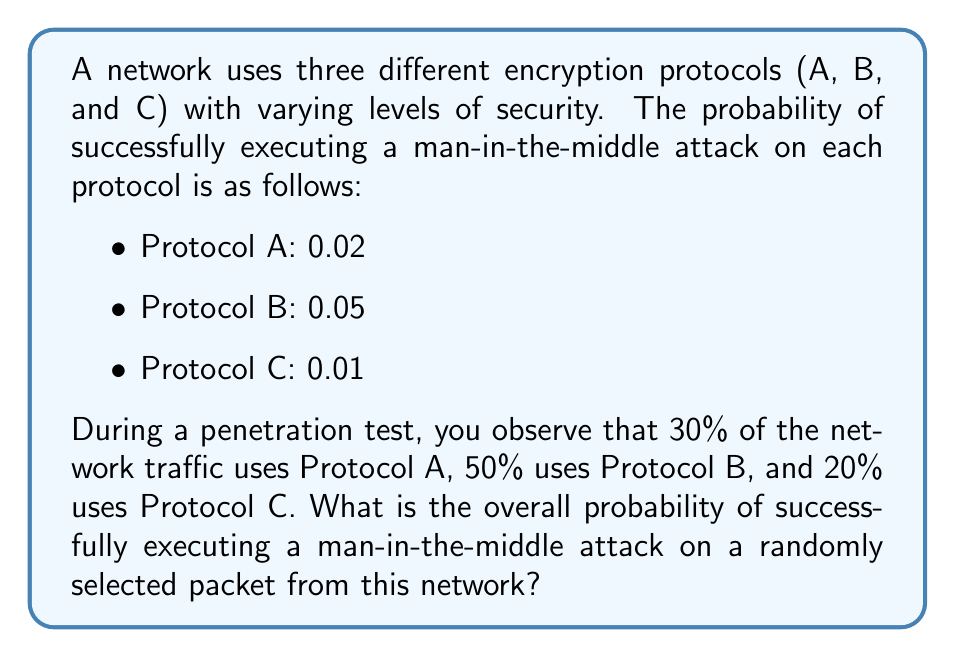Give your solution to this math problem. To solve this problem, we need to use the law of total probability. Let's break it down step-by-step:

1. Define events:
   - Let $S$ be the event of a successful man-in-the-middle attack
   - Let $A$, $B$, and $C$ represent the events of selecting a packet using Protocol A, B, and C respectively

2. Given probabilities:
   - $P(S|A) = 0.02$ (probability of success given Protocol A)
   - $P(S|B) = 0.05$ (probability of success given Protocol B)
   - $P(S|C) = 0.01$ (probability of success given Protocol C)
   - $P(A) = 0.30$ (probability of selecting Protocol A)
   - $P(B) = 0.50$ (probability of selecting Protocol B)
   - $P(C) = 0.20$ (probability of selecting Protocol C)

3. Apply the law of total probability:
   $$P(S) = P(S|A)P(A) + P(S|B)P(B) + P(S|C)P(C)$$

4. Substitute the values:
   $$P(S) = (0.02 \times 0.30) + (0.05 \times 0.50) + (0.01 \times 0.20)$$

5. Calculate:
   $$P(S) = 0.006 + 0.025 + 0.002 = 0.033$$

Therefore, the overall probability of successfully executing a man-in-the-middle attack on a randomly selected packet is 0.033 or 3.3%.
Answer: 0.033 